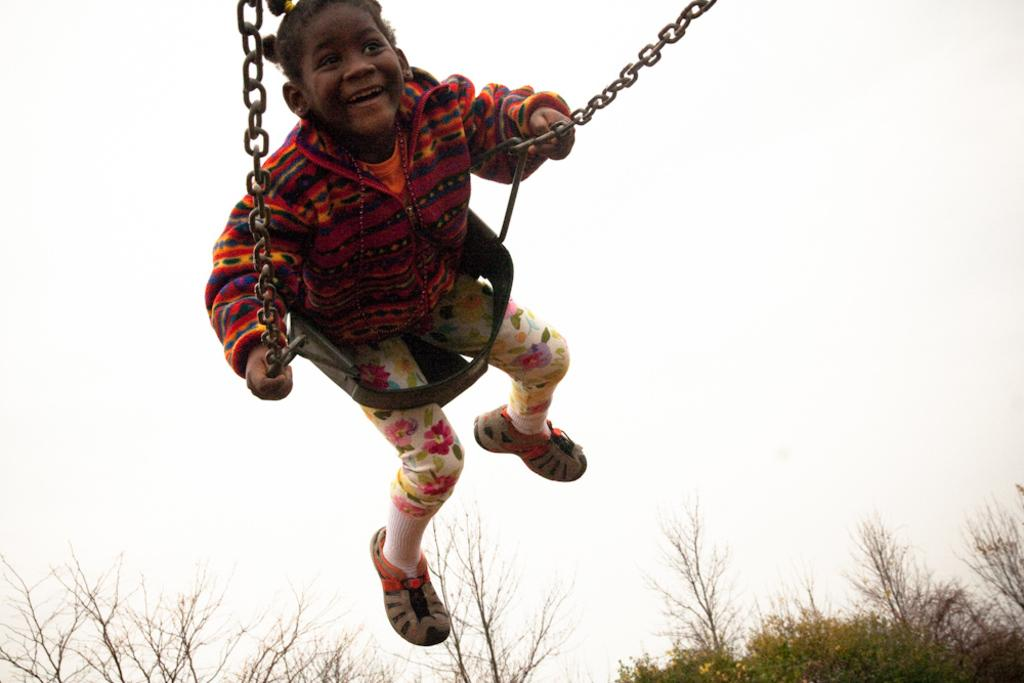Who is the main subject in the image? There is a girl in the image. What is the girl doing in the image? The girl is sitting in a chain swing. What can be seen in the background of the image? There are trees at the bottom of the image. How many eyes does the muscle have in the image? There is no muscle or eyes present in the image. 